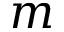<formula> <loc_0><loc_0><loc_500><loc_500>m</formula> 